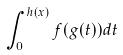<formula> <loc_0><loc_0><loc_500><loc_500>\int _ { 0 } ^ { h ( x ) } f ( g ( t ) ) d t</formula> 